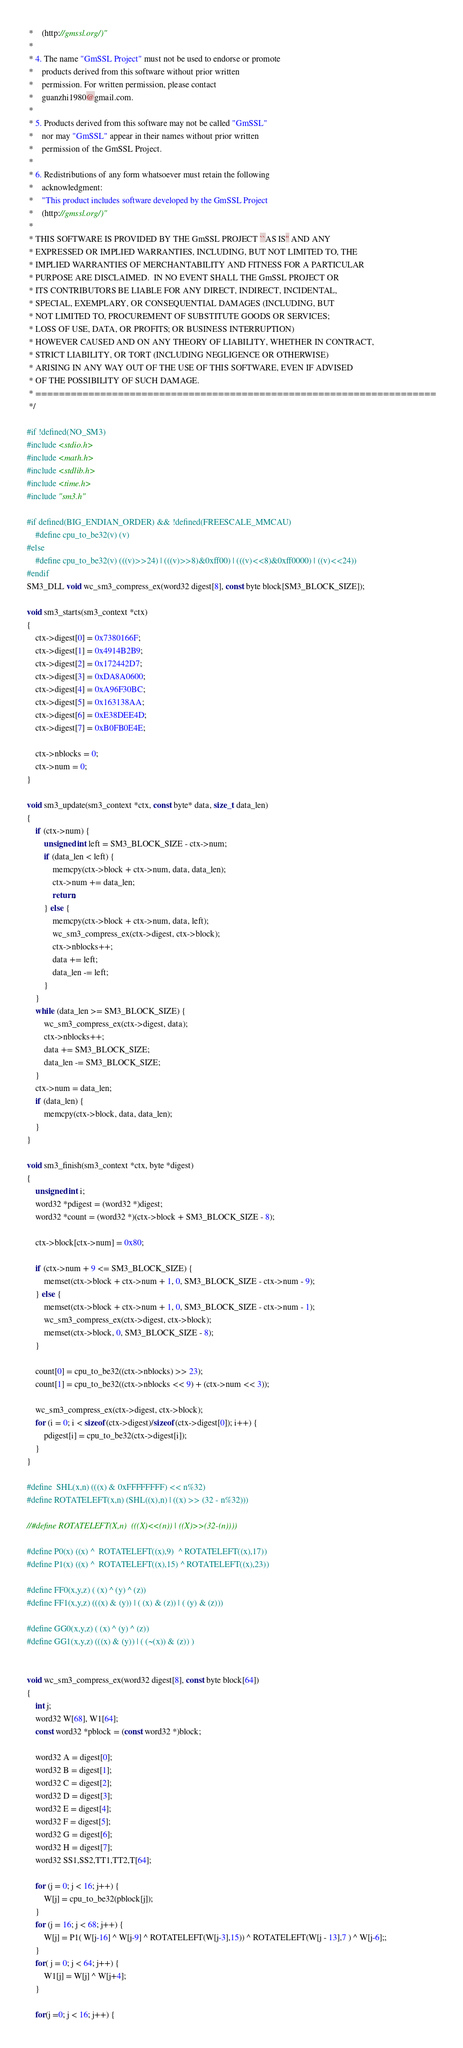Convert code to text. <code><loc_0><loc_0><loc_500><loc_500><_C_> *    (http://gmssl.org/)"
 *
 * 4. The name "GmSSL Project" must not be used to endorse or promote
 *    products derived from this software without prior written
 *    permission. For written permission, please contact
 *    guanzhi1980@gmail.com.
 *
 * 5. Products derived from this software may not be called "GmSSL"
 *    nor may "GmSSL" appear in their names without prior written
 *    permission of the GmSSL Project.
 *
 * 6. Redistributions of any form whatsoever must retain the following
 *    acknowledgment:
 *    "This product includes software developed by the GmSSL Project
 *    (http://gmssl.org/)"
 *
 * THIS SOFTWARE IS PROVIDED BY THE GmSSL PROJECT ``AS IS'' AND ANY
 * EXPRESSED OR IMPLIED WARRANTIES, INCLUDING, BUT NOT LIMITED TO, THE
 * IMPLIED WARRANTIES OF MERCHANTABILITY AND FITNESS FOR A PARTICULAR
 * PURPOSE ARE DISCLAIMED.  IN NO EVENT SHALL THE GmSSL PROJECT OR
 * ITS CONTRIBUTORS BE LIABLE FOR ANY DIRECT, INDIRECT, INCIDENTAL,
 * SPECIAL, EXEMPLARY, OR CONSEQUENTIAL DAMAGES (INCLUDING, BUT
 * NOT LIMITED TO, PROCUREMENT OF SUBSTITUTE GOODS OR SERVICES;
 * LOSS OF USE, DATA, OR PROFITS; OR BUSINESS INTERRUPTION)
 * HOWEVER CAUSED AND ON ANY THEORY OF LIABILITY, WHETHER IN CONTRACT,
 * STRICT LIABILITY, OR TORT (INCLUDING NEGLIGENCE OR OTHERWISE)
 * ARISING IN ANY WAY OUT OF THE USE OF THIS SOFTWARE, EVEN IF ADVISED
 * OF THE POSSIBILITY OF SUCH DAMAGE.
 * ====================================================================
 */

#if !defined(NO_SM3)
#include <stdio.h>
#include <math.h>
#include <stdlib.h>
#include <time.h>
#include "sm3.h"

#if defined(BIG_ENDIAN_ORDER) && !defined(FREESCALE_MMCAU)
    #define cpu_to_be32(v) (v)
#else
	#define cpu_to_be32(v) (((v)>>24) | (((v)>>8)&0xff00) | (((v)<<8)&0xff0000) | ((v)<<24))
#endif
SM3_DLL void wc_sm3_compress_ex(word32 digest[8], const byte block[SM3_BLOCK_SIZE]);

void sm3_starts(sm3_context *ctx)
{
	ctx->digest[0] = 0x7380166F;
	ctx->digest[1] = 0x4914B2B9;
	ctx->digest[2] = 0x172442D7;
	ctx->digest[3] = 0xDA8A0600;
	ctx->digest[4] = 0xA96F30BC;
	ctx->digest[5] = 0x163138AA;
	ctx->digest[6] = 0xE38DEE4D;
	ctx->digest[7] = 0xB0FB0E4E;

	ctx->nblocks = 0;
	ctx->num = 0;
}

void sm3_update(sm3_context *ctx, const byte* data, size_t data_len)
{
	if (ctx->num) {
		unsigned int left = SM3_BLOCK_SIZE - ctx->num;
		if (data_len < left) {
			memcpy(ctx->block + ctx->num, data, data_len);
			ctx->num += data_len;
			return;
		} else {
			memcpy(ctx->block + ctx->num, data, left);
			wc_sm3_compress_ex(ctx->digest, ctx->block);
			ctx->nblocks++;
			data += left;
			data_len -= left;
		}
	}
	while (data_len >= SM3_BLOCK_SIZE) {
		wc_sm3_compress_ex(ctx->digest, data);
		ctx->nblocks++;
		data += SM3_BLOCK_SIZE;
		data_len -= SM3_BLOCK_SIZE;
	}
	ctx->num = data_len;
	if (data_len) {
		memcpy(ctx->block, data, data_len);
	}
}

void sm3_finish(sm3_context *ctx, byte *digest)
{
	unsigned int i;
	word32 *pdigest = (word32 *)digest;
	word32 *count = (word32 *)(ctx->block + SM3_BLOCK_SIZE - 8);

	ctx->block[ctx->num] = 0x80;

	if (ctx->num + 9 <= SM3_BLOCK_SIZE) {
		memset(ctx->block + ctx->num + 1, 0, SM3_BLOCK_SIZE - ctx->num - 9);
	} else {
		memset(ctx->block + ctx->num + 1, 0, SM3_BLOCK_SIZE - ctx->num - 1);
		wc_sm3_compress_ex(ctx->digest, ctx->block);
		memset(ctx->block, 0, SM3_BLOCK_SIZE - 8);
	}

	count[0] = cpu_to_be32((ctx->nblocks) >> 23);
	count[1] = cpu_to_be32((ctx->nblocks << 9) + (ctx->num << 3));

	wc_sm3_compress_ex(ctx->digest, ctx->block);
	for (i = 0; i < sizeof(ctx->digest)/sizeof(ctx->digest[0]); i++) {
		pdigest[i] = cpu_to_be32(ctx->digest[i]);
	}
}

#define  SHL(x,n) (((x) & 0xFFFFFFFF) << n%32) 
#define ROTATELEFT(x,n) (SHL((x),n) | ((x) >> (32 - n%32)))

//#define ROTATELEFT(X,n)  (((X)<<(n)) | ((X)>>(32-(n))))

#define P0(x) ((x) ^  ROTATELEFT((x),9)  ^ ROTATELEFT((x),17))
#define P1(x) ((x) ^  ROTATELEFT((x),15) ^ ROTATELEFT((x),23))

#define FF0(x,y,z) ( (x) ^ (y) ^ (z))
#define FF1(x,y,z) (((x) & (y)) | ( (x) & (z)) | ( (y) & (z)))

#define GG0(x,y,z) ( (x) ^ (y) ^ (z))
#define GG1(x,y,z) (((x) & (y)) | ( (~(x)) & (z)) )


void wc_sm3_compress_ex(word32 digest[8], const byte block[64])
{
	int j;
	word32 W[68], W1[64];
	const word32 *pblock = (const word32 *)block;

	word32 A = digest[0];
	word32 B = digest[1];
	word32 C = digest[2];
	word32 D = digest[3];
	word32 E = digest[4];
	word32 F = digest[5];
	word32 G = digest[6];
	word32 H = digest[7];
	word32 SS1,SS2,TT1,TT2,T[64];

	for (j = 0; j < 16; j++) {
		W[j] = cpu_to_be32(pblock[j]);
	}
	for (j = 16; j < 68; j++) {
		W[j] = P1( W[j-16] ^ W[j-9] ^ ROTATELEFT(W[j-3],15)) ^ ROTATELEFT(W[j - 13],7 ) ^ W[j-6];;
	}
	for( j = 0; j < 64; j++) {
		W1[j] = W[j] ^ W[j+4];
	}

	for(j =0; j < 16; j++) {
</code> 